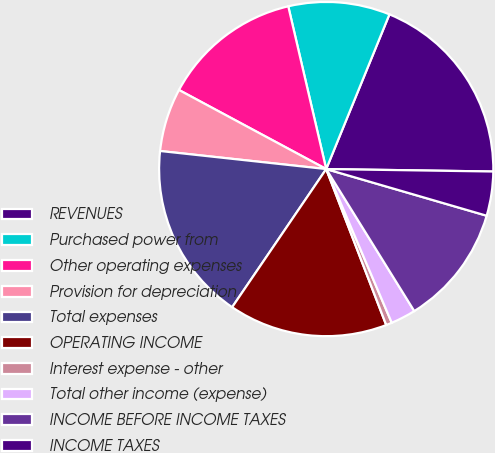Convert chart. <chart><loc_0><loc_0><loc_500><loc_500><pie_chart><fcel>REVENUES<fcel>Purchased power from<fcel>Other operating expenses<fcel>Provision for depreciation<fcel>Total expenses<fcel>OPERATING INCOME<fcel>Interest expense - other<fcel>Total other income (expense)<fcel>INCOME BEFORE INCOME TAXES<fcel>INCOME TAXES<nl><fcel>19.06%<fcel>9.82%<fcel>13.51%<fcel>6.12%<fcel>17.21%<fcel>15.36%<fcel>0.57%<fcel>2.42%<fcel>11.66%<fcel>4.27%<nl></chart> 